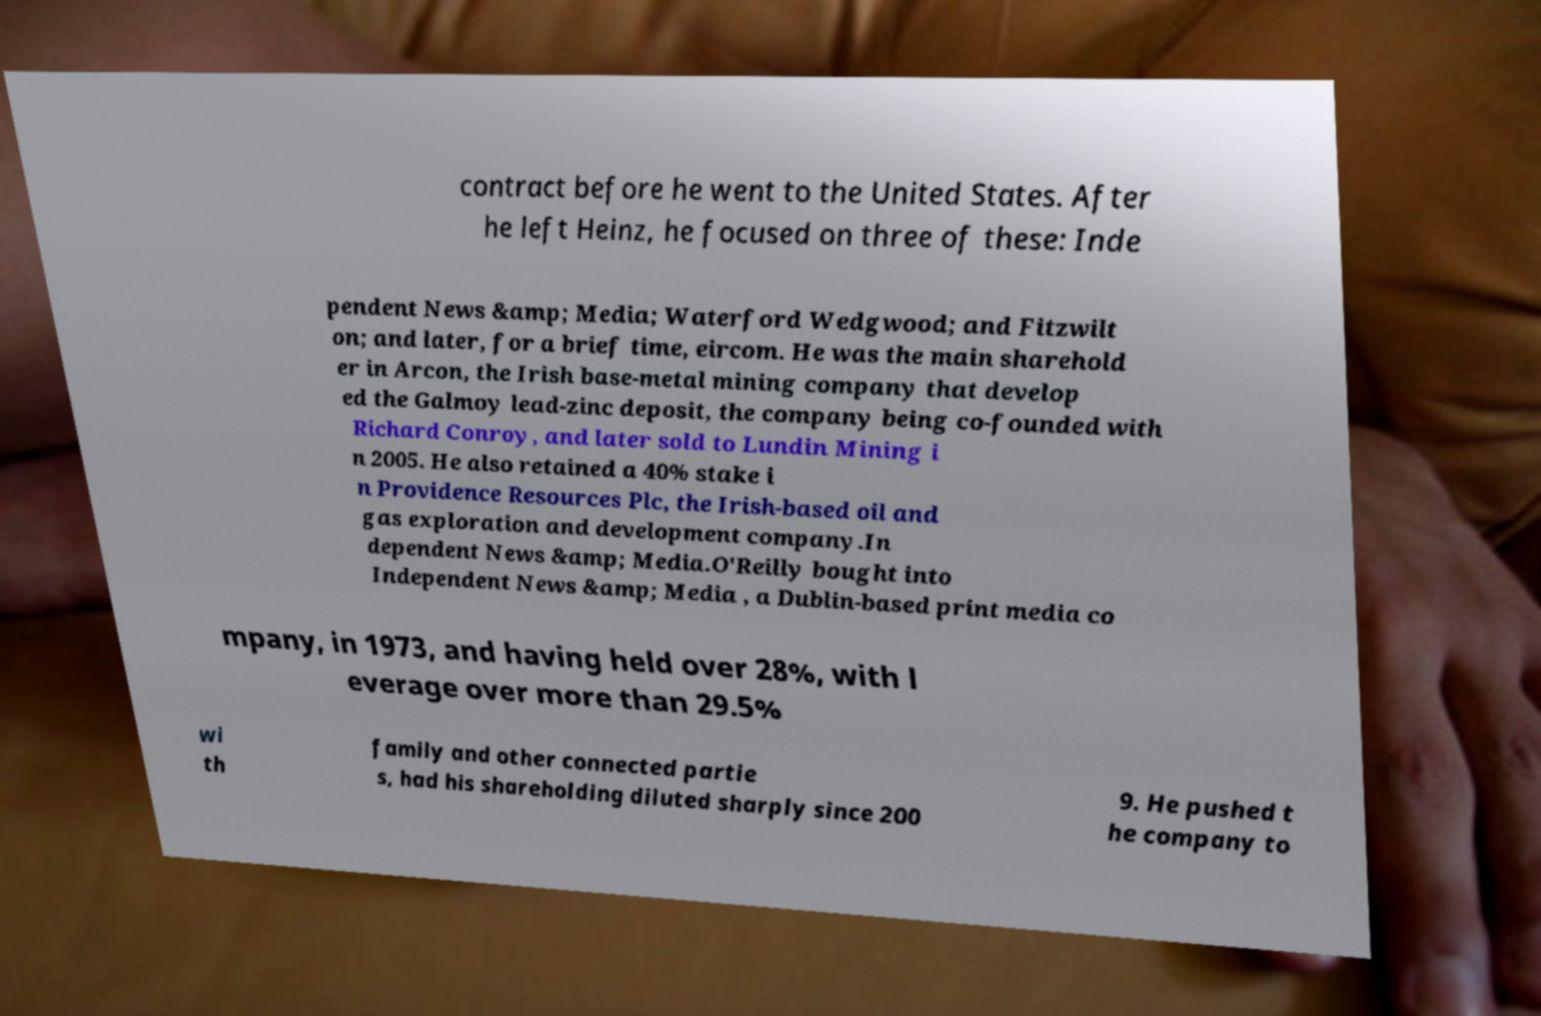There's text embedded in this image that I need extracted. Can you transcribe it verbatim? contract before he went to the United States. After he left Heinz, he focused on three of these: Inde pendent News &amp; Media; Waterford Wedgwood; and Fitzwilt on; and later, for a brief time, eircom. He was the main sharehold er in Arcon, the Irish base-metal mining company that develop ed the Galmoy lead-zinc deposit, the company being co-founded with Richard Conroy, and later sold to Lundin Mining i n 2005. He also retained a 40% stake i n Providence Resources Plc, the Irish-based oil and gas exploration and development company.In dependent News &amp; Media.O'Reilly bought into Independent News &amp; Media , a Dublin-based print media co mpany, in 1973, and having held over 28%, with l everage over more than 29.5% wi th family and other connected partie s, had his shareholding diluted sharply since 200 9. He pushed t he company to 